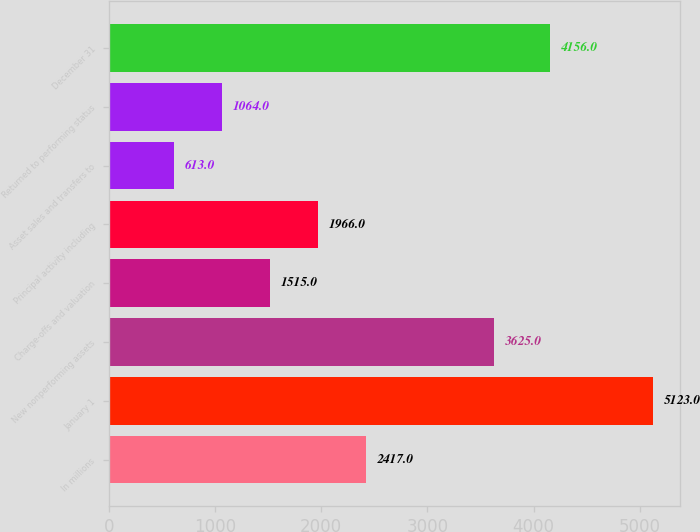Convert chart to OTSL. <chart><loc_0><loc_0><loc_500><loc_500><bar_chart><fcel>In millions<fcel>January 1<fcel>New nonperforming assets<fcel>Charge-offs and valuation<fcel>Principal activity including<fcel>Asset sales and transfers to<fcel>Returned to performing status<fcel>December 31<nl><fcel>2417<fcel>5123<fcel>3625<fcel>1515<fcel>1966<fcel>613<fcel>1064<fcel>4156<nl></chart> 